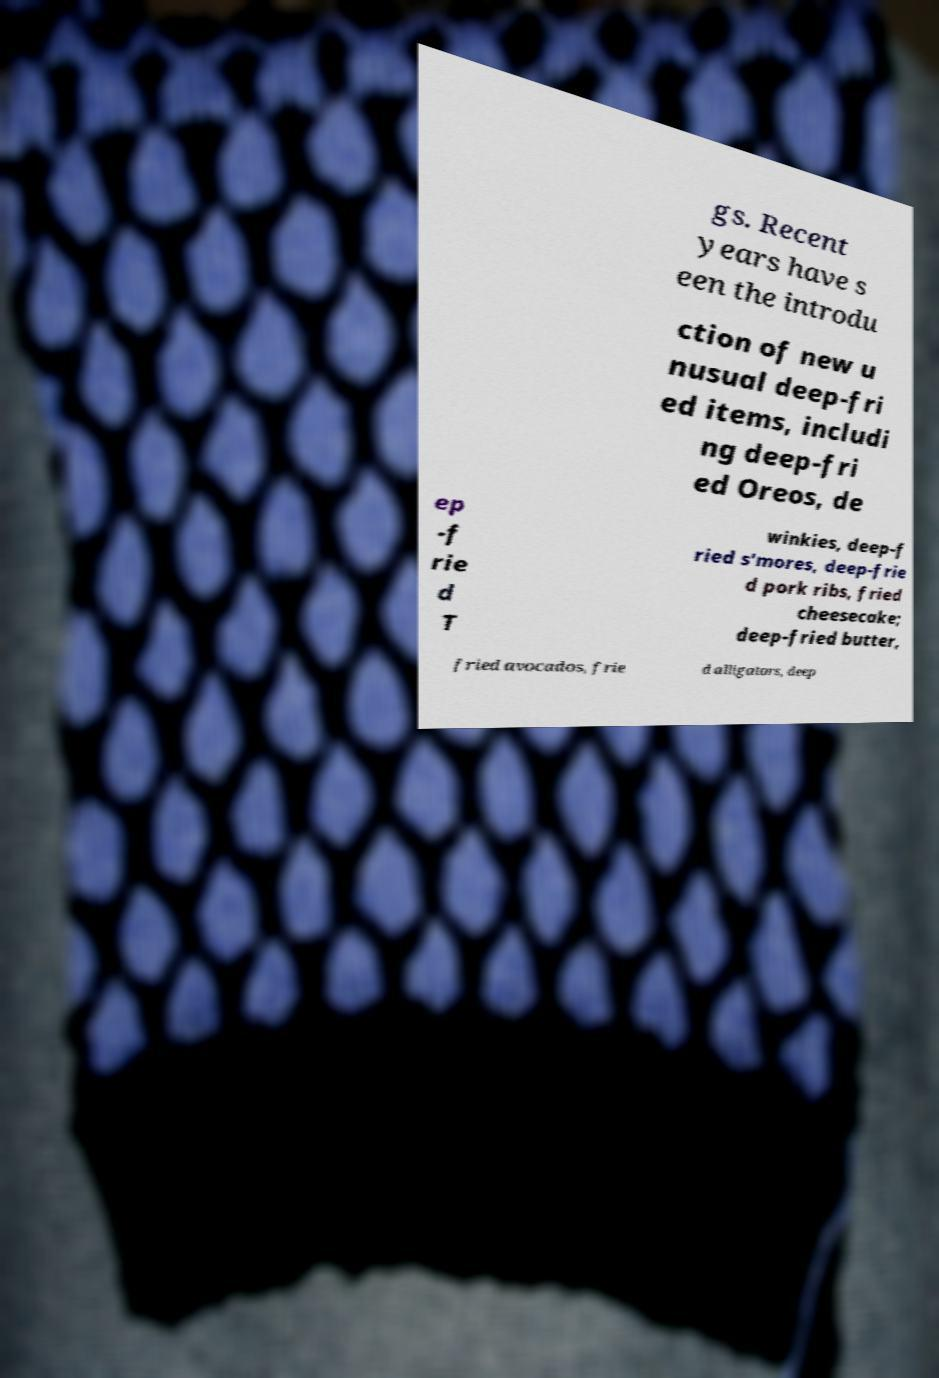For documentation purposes, I need the text within this image transcribed. Could you provide that? gs. Recent years have s een the introdu ction of new u nusual deep-fri ed items, includi ng deep-fri ed Oreos, de ep -f rie d T winkies, deep-f ried s'mores, deep-frie d pork ribs, fried cheesecake; deep-fried butter, fried avocados, frie d alligators, deep 